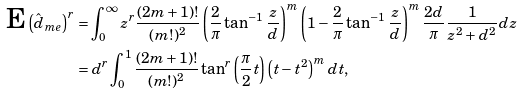Convert formula to latex. <formula><loc_0><loc_0><loc_500><loc_500>\text {E} \left ( \hat { d } _ { m e } \right ) ^ { r } & = \int _ { 0 } ^ { \infty } z ^ { r } \frac { ( 2 m + 1 ) ! } { ( m ! ) ^ { 2 } } \left ( \frac { 2 } { \pi } \tan ^ { - 1 } \frac { z } { d } \right ) ^ { m } \left ( 1 - \frac { 2 } { \pi } \tan ^ { - 1 } \frac { z } { d } \right ) ^ { m } \frac { 2 d } { \pi } \frac { 1 } { z ^ { 2 } + d ^ { 2 } } d z \\ & = d ^ { r } \int _ { 0 } ^ { 1 } \frac { ( 2 m + 1 ) ! } { ( m ! ) ^ { 2 } } \tan ^ { r } \left ( \frac { \pi } { 2 } t \right ) \left ( t - t ^ { 2 } \right ) ^ { m } d t ,</formula> 